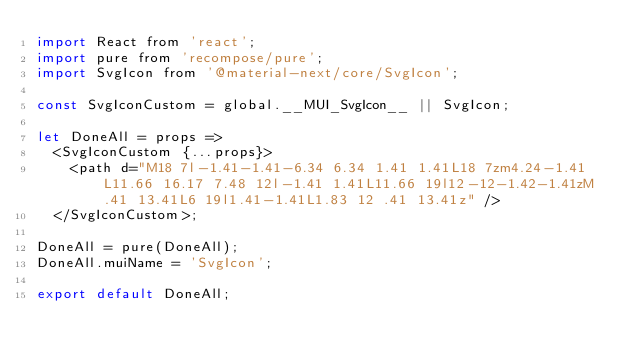Convert code to text. <code><loc_0><loc_0><loc_500><loc_500><_JavaScript_>import React from 'react';
import pure from 'recompose/pure';
import SvgIcon from '@material-next/core/SvgIcon';

const SvgIconCustom = global.__MUI_SvgIcon__ || SvgIcon;

let DoneAll = props =>
  <SvgIconCustom {...props}>
    <path d="M18 7l-1.41-1.41-6.34 6.34 1.41 1.41L18 7zm4.24-1.41L11.66 16.17 7.48 12l-1.41 1.41L11.66 19l12-12-1.42-1.41zM.41 13.41L6 19l1.41-1.41L1.83 12 .41 13.41z" />
  </SvgIconCustom>;

DoneAll = pure(DoneAll);
DoneAll.muiName = 'SvgIcon';

export default DoneAll;
</code> 